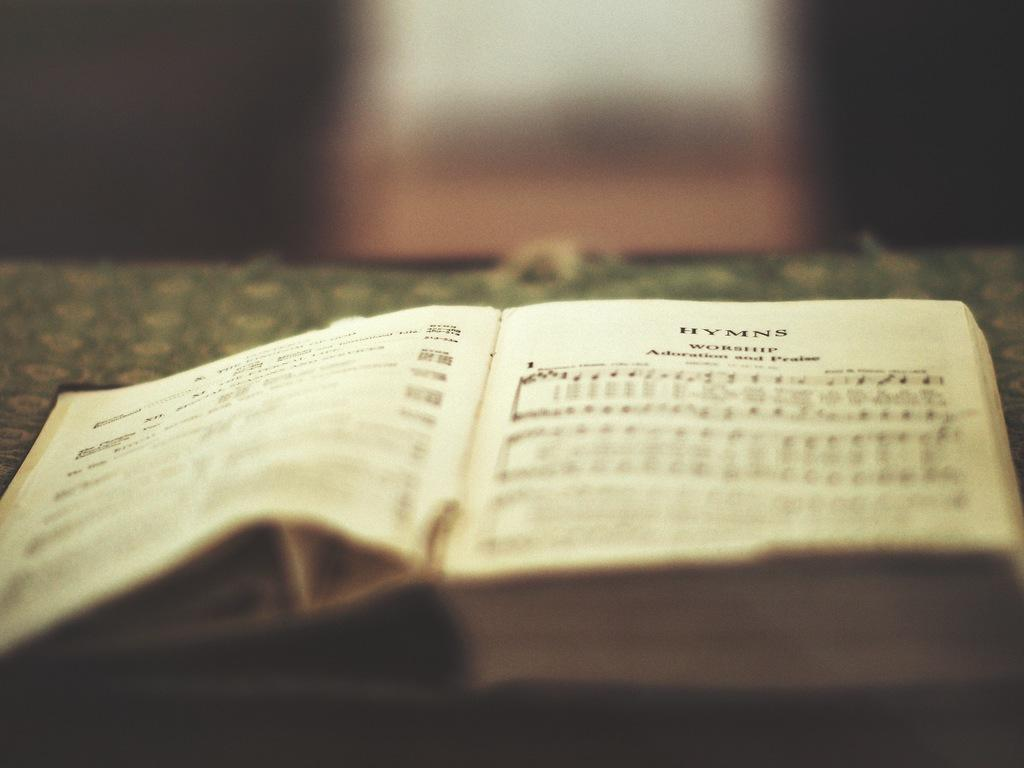<image>
Give a short and clear explanation of the subsequent image. open music book sits on the table music hymns 